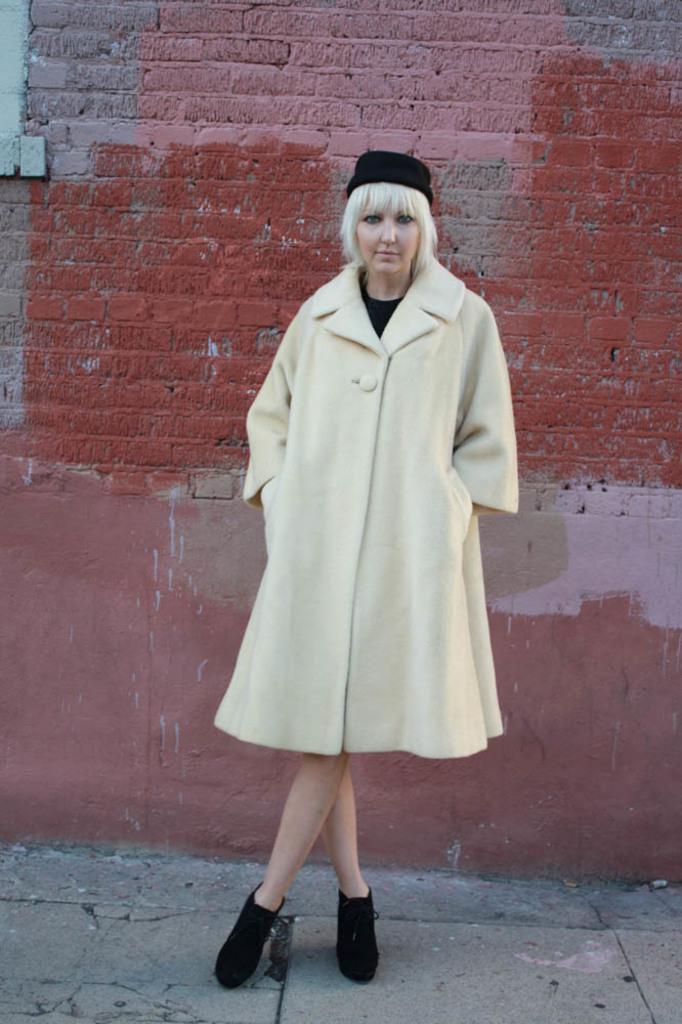Please provide a concise description of this image. This image consists of a woman. She is standing. She is wearing a coat, cap and hat. The coat is in cream color. There is a wall behind her. 